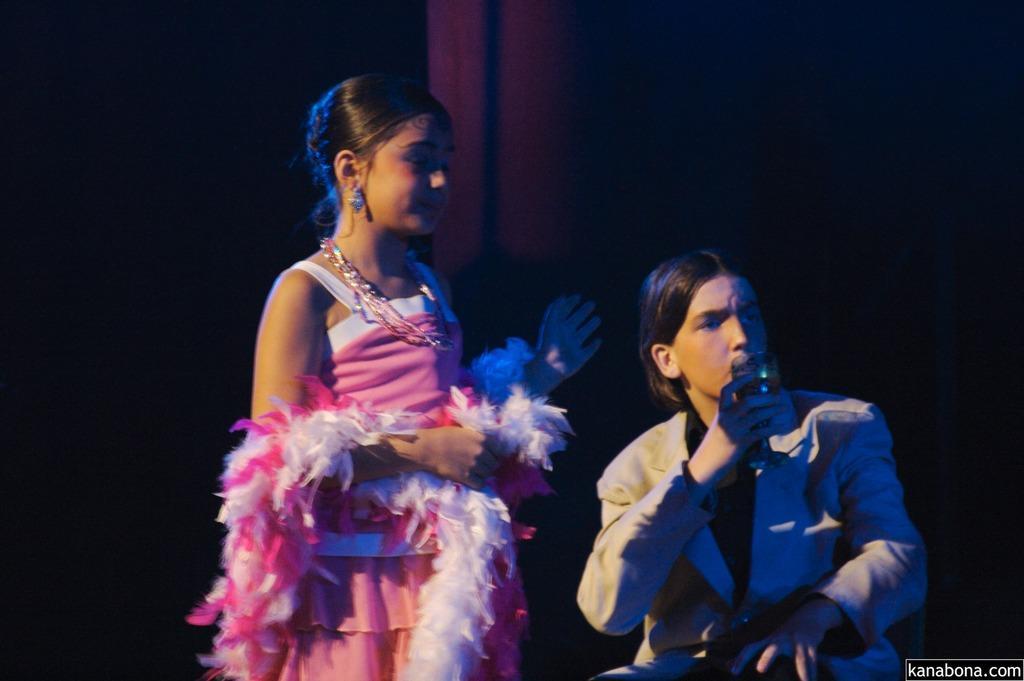Could you give a brief overview of what you see in this image? In this picture we can see two persons and he is holding a glass with his hand. There is a dark background. 